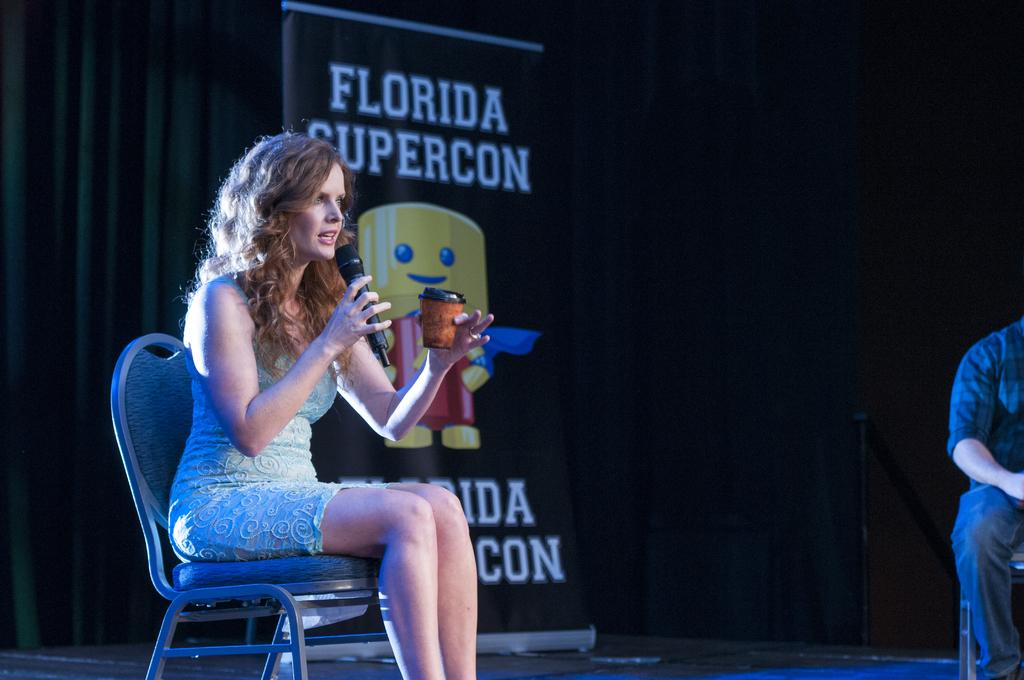Who is the main subject in the image? There is a woman in the image. What is the woman doing in the image? The woman is sitting in a chair and holding a microphone in her hand. What else is the woman holding in the image? The woman is holding a cup in her other hand. What can be seen in the background of the image? There is a flex banner with the title "Florida supercon" in the image. What type of tin can be seen on the woman's head in the image? There is no tin present on the woman's head in the image. What kind of patch is sewn onto the woman's shirt in the image? There is no patch visible on the woman's shirt in the image. 